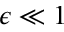Convert formula to latex. <formula><loc_0><loc_0><loc_500><loc_500>\epsilon \ll 1</formula> 